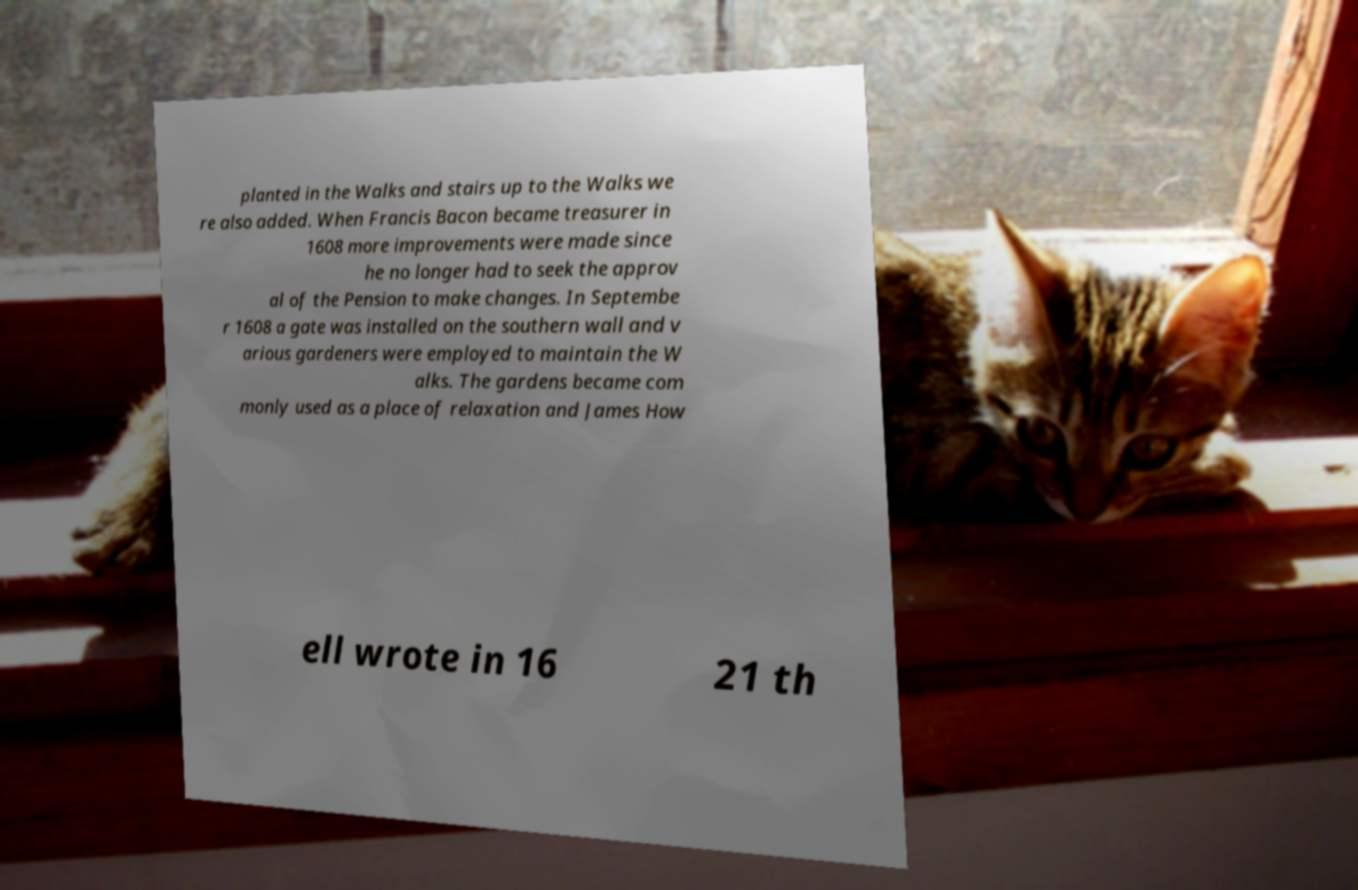There's text embedded in this image that I need extracted. Can you transcribe it verbatim? planted in the Walks and stairs up to the Walks we re also added. When Francis Bacon became treasurer in 1608 more improvements were made since he no longer had to seek the approv al of the Pension to make changes. In Septembe r 1608 a gate was installed on the southern wall and v arious gardeners were employed to maintain the W alks. The gardens became com monly used as a place of relaxation and James How ell wrote in 16 21 th 